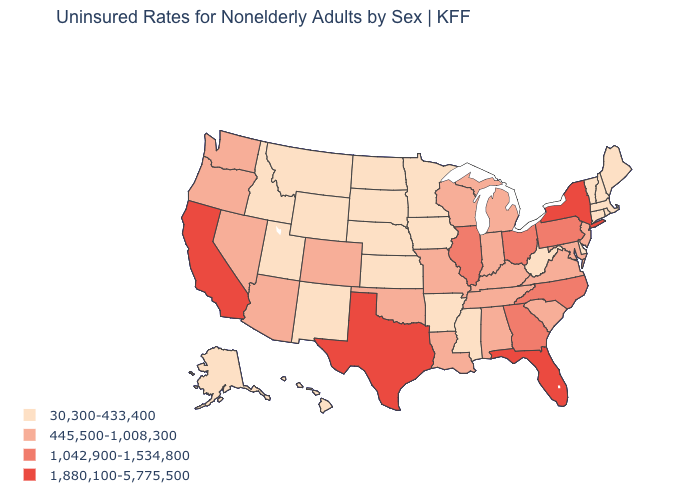Which states have the highest value in the USA?
Answer briefly. California, Florida, New York, Texas. What is the highest value in the USA?
Write a very short answer. 1,880,100-5,775,500. How many symbols are there in the legend?
Concise answer only. 4. Which states have the lowest value in the USA?
Be succinct. Alaska, Arkansas, Connecticut, Delaware, Hawaii, Idaho, Iowa, Kansas, Maine, Massachusetts, Minnesota, Mississippi, Montana, Nebraska, New Hampshire, New Mexico, North Dakota, Rhode Island, South Dakota, Utah, Vermont, West Virginia, Wyoming. Which states have the lowest value in the USA?
Write a very short answer. Alaska, Arkansas, Connecticut, Delaware, Hawaii, Idaho, Iowa, Kansas, Maine, Massachusetts, Minnesota, Mississippi, Montana, Nebraska, New Hampshire, New Mexico, North Dakota, Rhode Island, South Dakota, Utah, Vermont, West Virginia, Wyoming. Is the legend a continuous bar?
Concise answer only. No. Does the first symbol in the legend represent the smallest category?
Give a very brief answer. Yes. Does Vermont have the lowest value in the Northeast?
Keep it brief. Yes. What is the value of Utah?
Keep it brief. 30,300-433,400. Name the states that have a value in the range 1,042,900-1,534,800?
Quick response, please. Georgia, Illinois, North Carolina, Ohio, Pennsylvania. How many symbols are there in the legend?
Answer briefly. 4. Name the states that have a value in the range 1,880,100-5,775,500?
Answer briefly. California, Florida, New York, Texas. Name the states that have a value in the range 1,880,100-5,775,500?
Be succinct. California, Florida, New York, Texas. What is the value of Illinois?
Give a very brief answer. 1,042,900-1,534,800. What is the lowest value in the USA?
Be succinct. 30,300-433,400. 